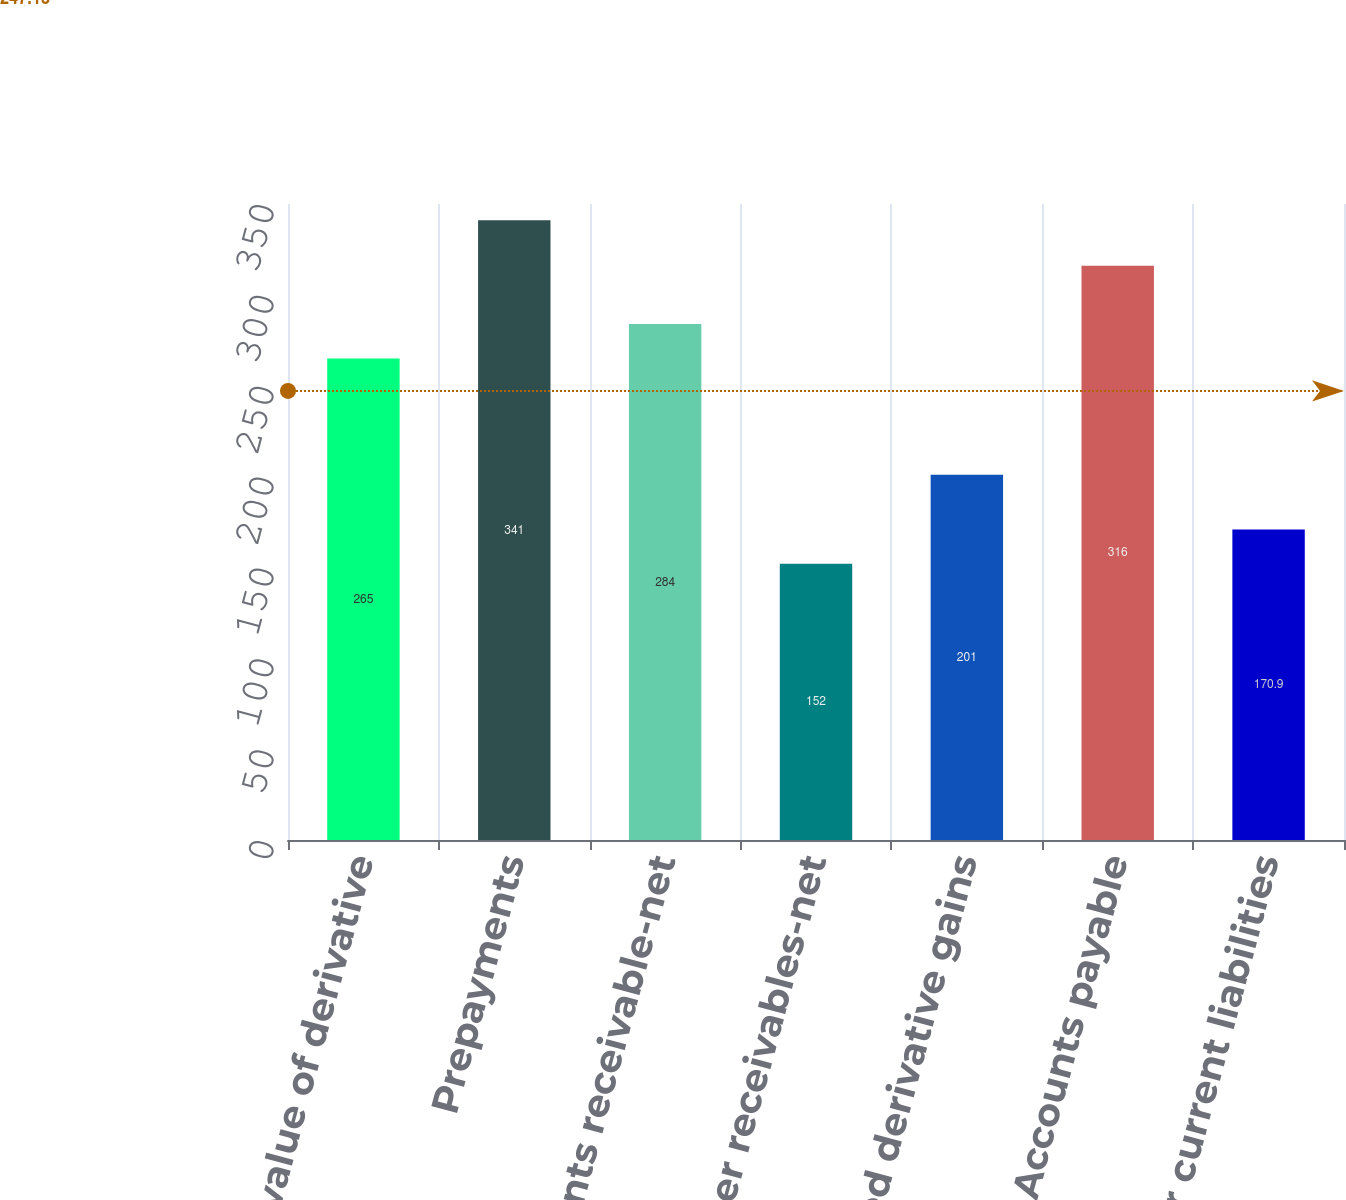Convert chart to OTSL. <chart><loc_0><loc_0><loc_500><loc_500><bar_chart><fcel>Fair value of derivative<fcel>Prepayments<fcel>Accounts receivable-net<fcel>Other receivables-net<fcel>Deferred derivative gains<fcel>Accounts payable<fcel>Other current liabilities<nl><fcel>265<fcel>341<fcel>284<fcel>152<fcel>201<fcel>316<fcel>170.9<nl></chart> 